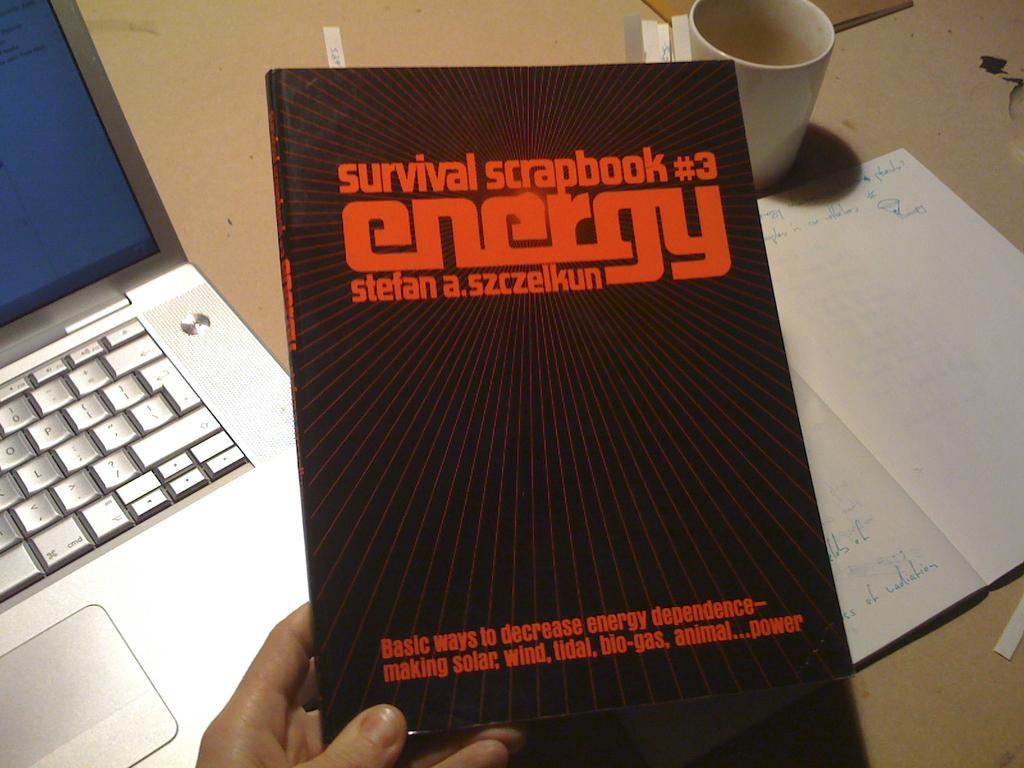<image>
Create a compact narrative representing the image presented. a book that is titled 'survival scrabook #3 energy' 